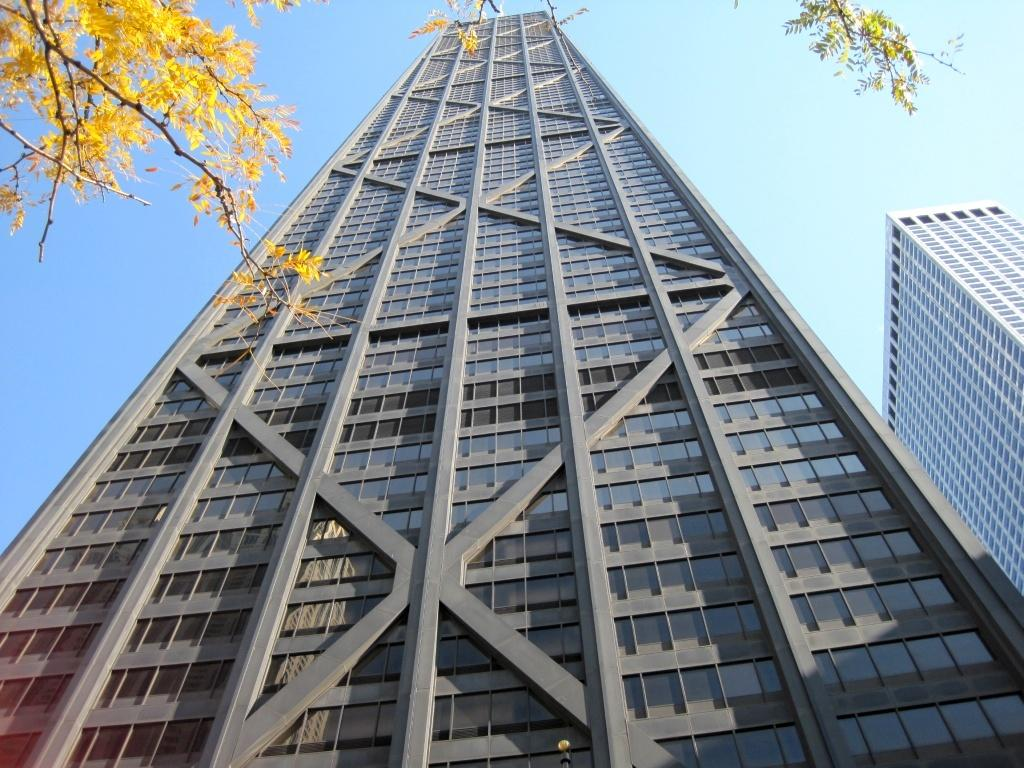What type of structures can be seen in the image? There are buildings in the image. What can be seen in the background of the image? The sky is visible in the background of the image. What type of vegetation is present at the top of the image? Leaves and stems are present at the top of the image. Where is the pin located in the image? There is no pin present in the image. What type of trousers are the buildings wearing in the image? Buildings do not wear trousers, as they are inanimate structures. 